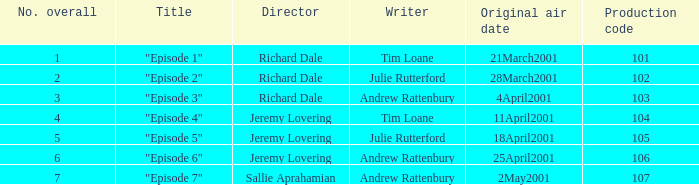What is the highest production code of an episode written by Tim Loane? 104.0. 